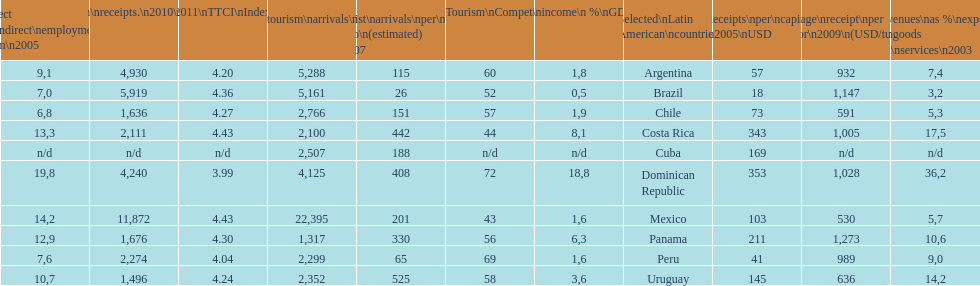What is the last country listed on this chart? Uruguay. 